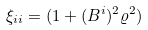Convert formula to latex. <formula><loc_0><loc_0><loc_500><loc_500>\xi _ { i i } = ( 1 + ( B ^ { i } ) ^ { 2 } \varrho ^ { 2 } )</formula> 